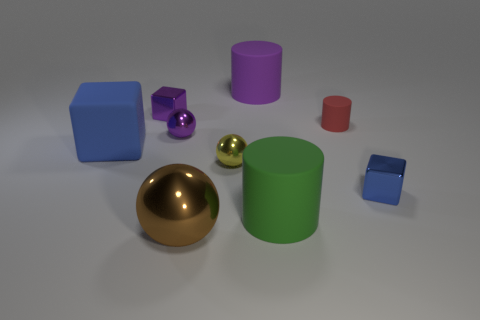Add 1 purple metallic things. How many objects exist? 10 Subtract all balls. How many objects are left? 6 Add 8 tiny blue shiny things. How many tiny blue shiny things exist? 9 Subtract 1 purple blocks. How many objects are left? 8 Subtract all blue cubes. Subtract all green matte objects. How many objects are left? 6 Add 8 purple spheres. How many purple spheres are left? 9 